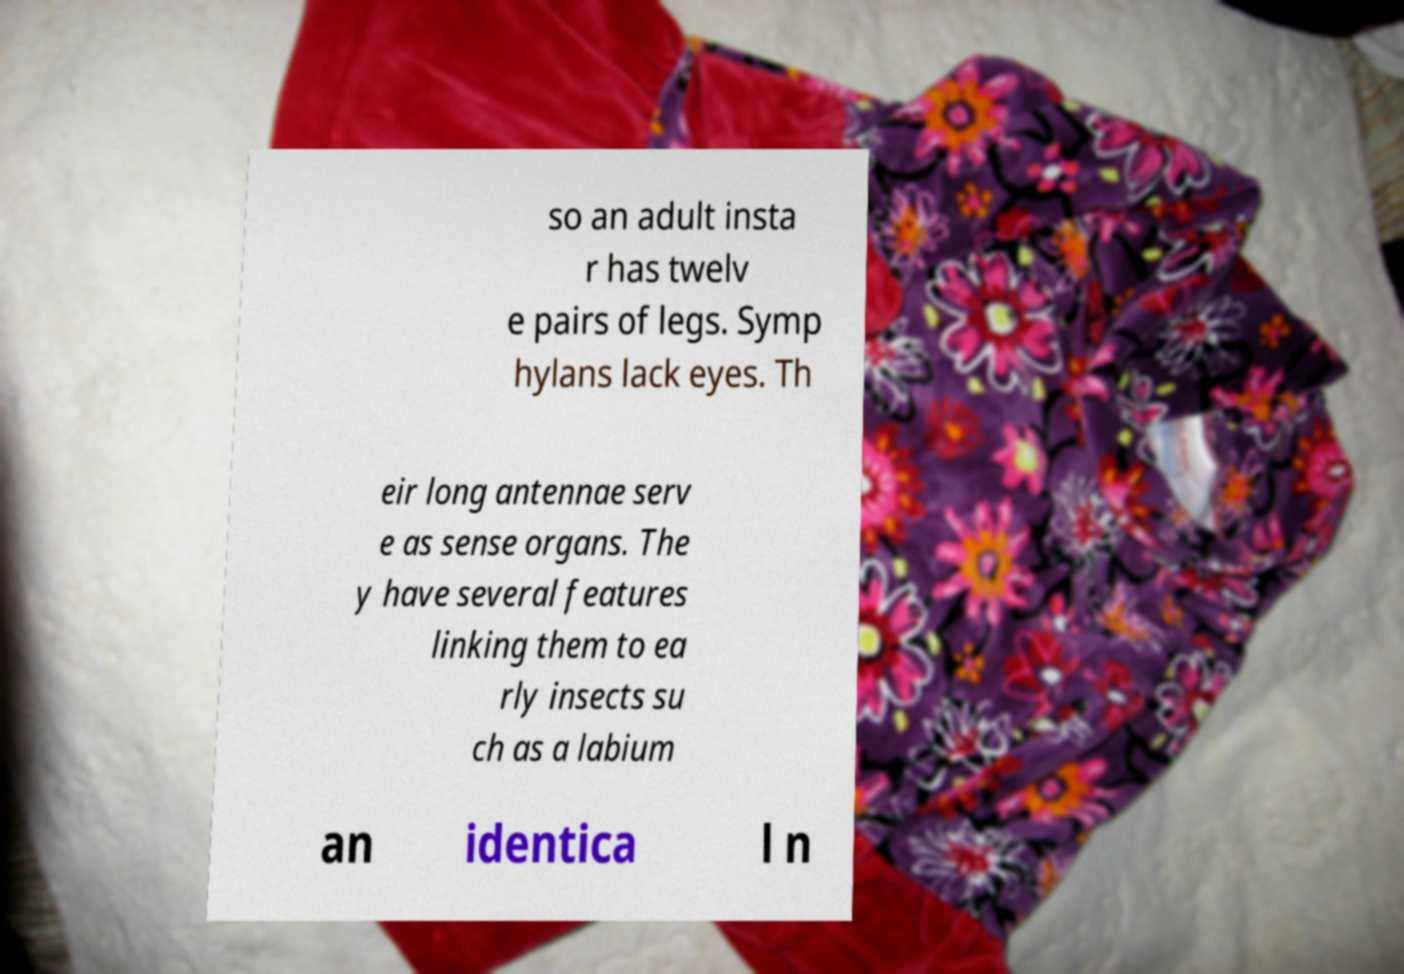There's text embedded in this image that I need extracted. Can you transcribe it verbatim? so an adult insta r has twelv e pairs of legs. Symp hylans lack eyes. Th eir long antennae serv e as sense organs. The y have several features linking them to ea rly insects su ch as a labium an identica l n 